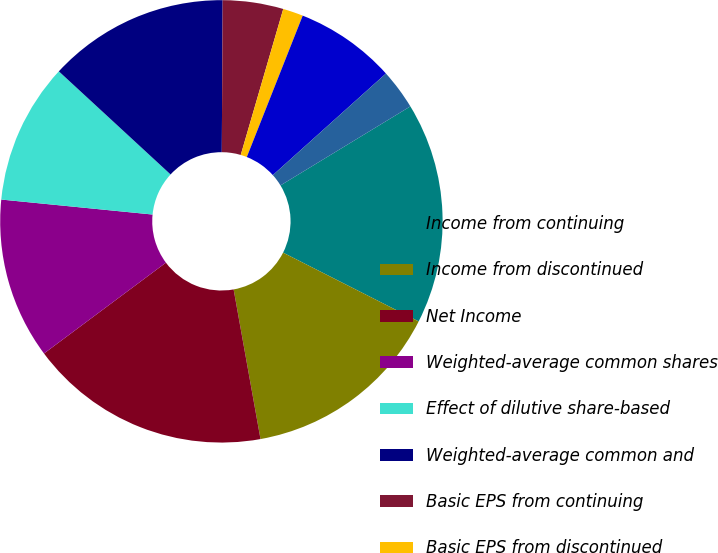<chart> <loc_0><loc_0><loc_500><loc_500><pie_chart><fcel>Income from continuing<fcel>Income from discontinued<fcel>Net Income<fcel>Weighted-average common shares<fcel>Effect of dilutive share-based<fcel>Weighted-average common and<fcel>Basic EPS from continuing<fcel>Basic EPS from discontinued<fcel>Basic EPS<fcel>Diluted EPS from continuing<nl><fcel>16.17%<fcel>14.7%<fcel>17.64%<fcel>11.76%<fcel>10.29%<fcel>13.23%<fcel>4.42%<fcel>1.48%<fcel>7.36%<fcel>2.95%<nl></chart> 